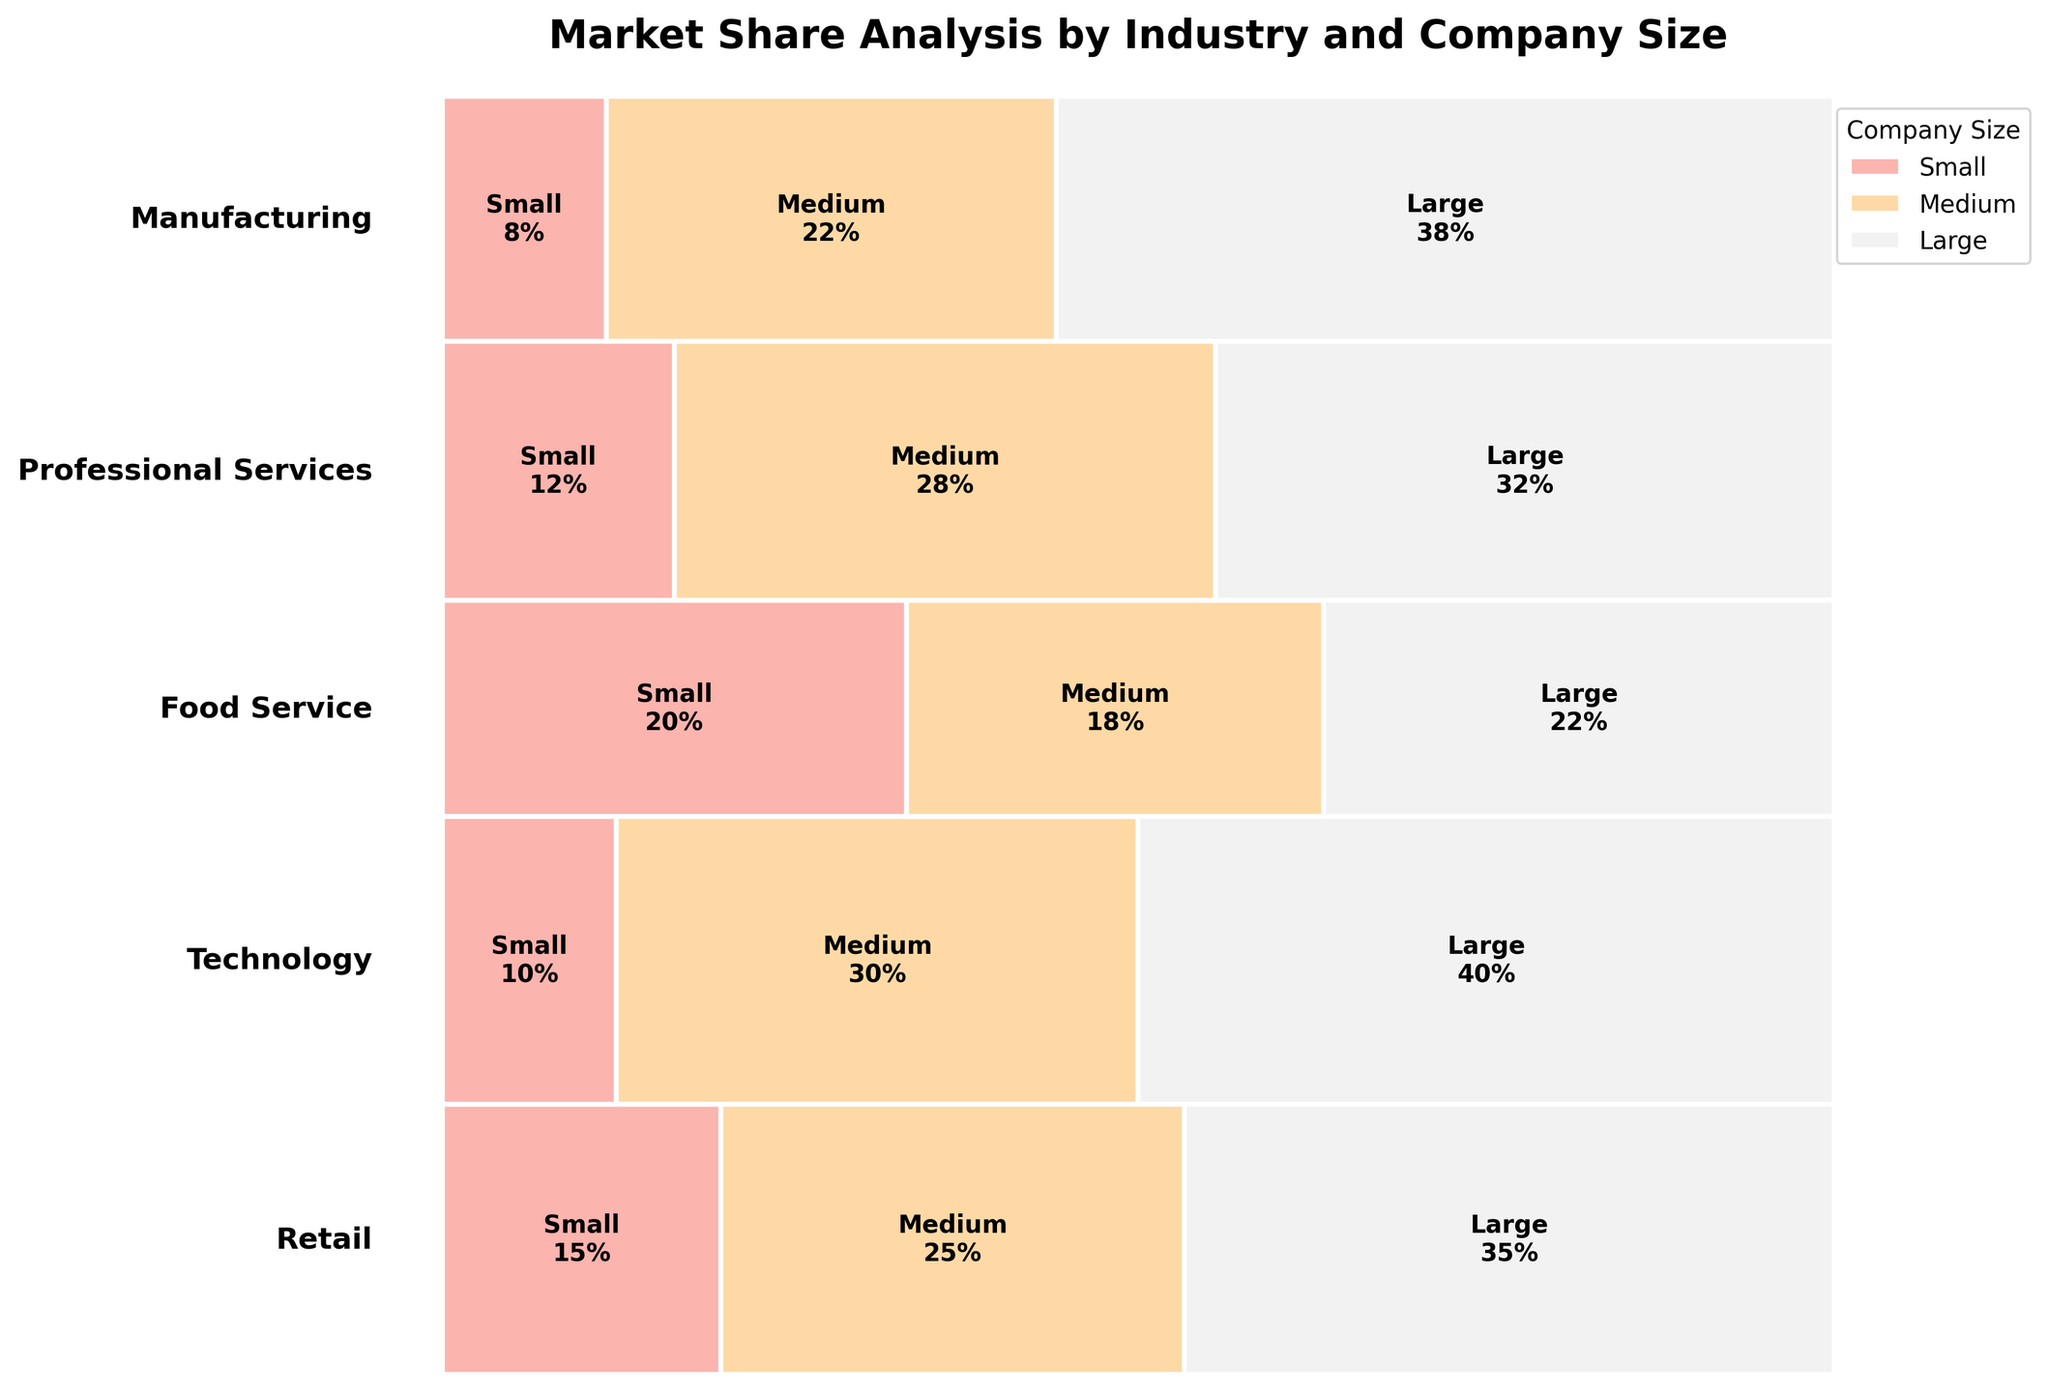What are the industry sectors shown on the plot? By looking at the left side legend of the plot, each industry sector is listed, which includes Retail, Technology, Food Service, Professional Services, and Manufacturing.
Answer: Retail, Technology, Food Service, Professional Services, Manufacturing Which industry sector has the largest market share for large companies? By referring to the widths of the rectangles representing large companies for each industry sector, the sector with the widest rectangle for large companies is Technology.
Answer: Technology What is the total market share of medium-sized companies across all industry sectors? To find the total market share for medium-sized companies, add up the market shares: 25 (Retail) + 30 (Technology) + 18 (Food Service) + 28 (Professional Services) + 22 (Manufacturing). The sum is 123%.
Answer: 123% Which company size has the highest market share within the Manufacturing sector? By comparing the rectangles within the Manufacturing sector, the largest rectangle in terms of width representing market share is for large companies with 38%.
Answer: Large How does the market share of small companies in Food Service compare to that in Retail? By examining the heights of the rectangles for small companies in both sectors, the market share is 20% in Food Service and 15% in Retail, indicating that the share in Food Service is higher.
Answer: Food Service is higher What is the average market share of large companies across all industry sectors? To find the average, sum the market shares of large companies: 35 (Retail) + 40 (Technology) + 22 (Food Service) + 32 (Professional Services) + 38 (Manufacturing). This equals 167. Divide this by the number of sectors, 5, resulting in an average of 33.4%.
Answer: 33.4% Which industry shows the most balanced market share distribution among different company sizes? By evaluating which industry has rectangles of similar widths among small, medium, and large sizes, Food Service appears most balanced, with shares at 20%, 18%, and 22%.
Answer: Food Service What is the total market share of small companies in all industry sectors combined? To get the total market share for small companies, add up the shares: 15 (Retail) + 10 (Technology) + 20 (Food Service) + 12 (Professional Services) + 8 (Manufacturing). This totals to 65%.
Answer: 65% Which company size is least represented in Professional Services, comparing their market shares? By comparing the rectangles for Professional Services, small companies are least represented, having the smallest share of 12%.
Answer: Small 